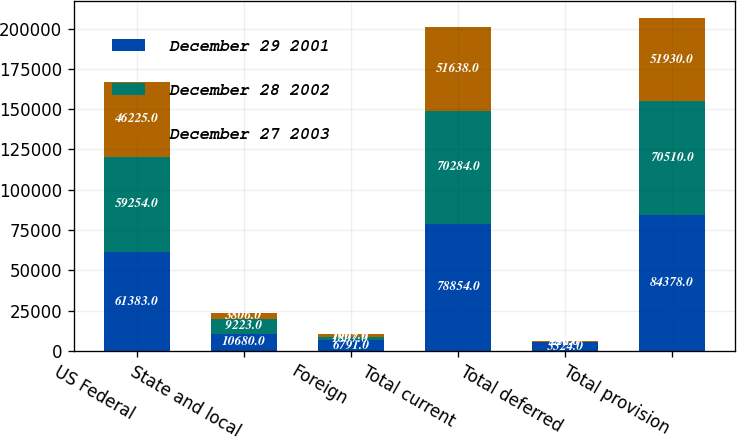<chart> <loc_0><loc_0><loc_500><loc_500><stacked_bar_chart><ecel><fcel>US Federal<fcel>State and local<fcel>Foreign<fcel>Total current<fcel>Total deferred<fcel>Total provision<nl><fcel>December 29 2001<fcel>61383<fcel>10680<fcel>6791<fcel>78854<fcel>5524<fcel>84378<nl><fcel>December 28 2002<fcel>59254<fcel>9223<fcel>1807<fcel>70284<fcel>226<fcel>70510<nl><fcel>December 27 2003<fcel>46225<fcel>3806<fcel>1607<fcel>51638<fcel>292<fcel>51930<nl></chart> 